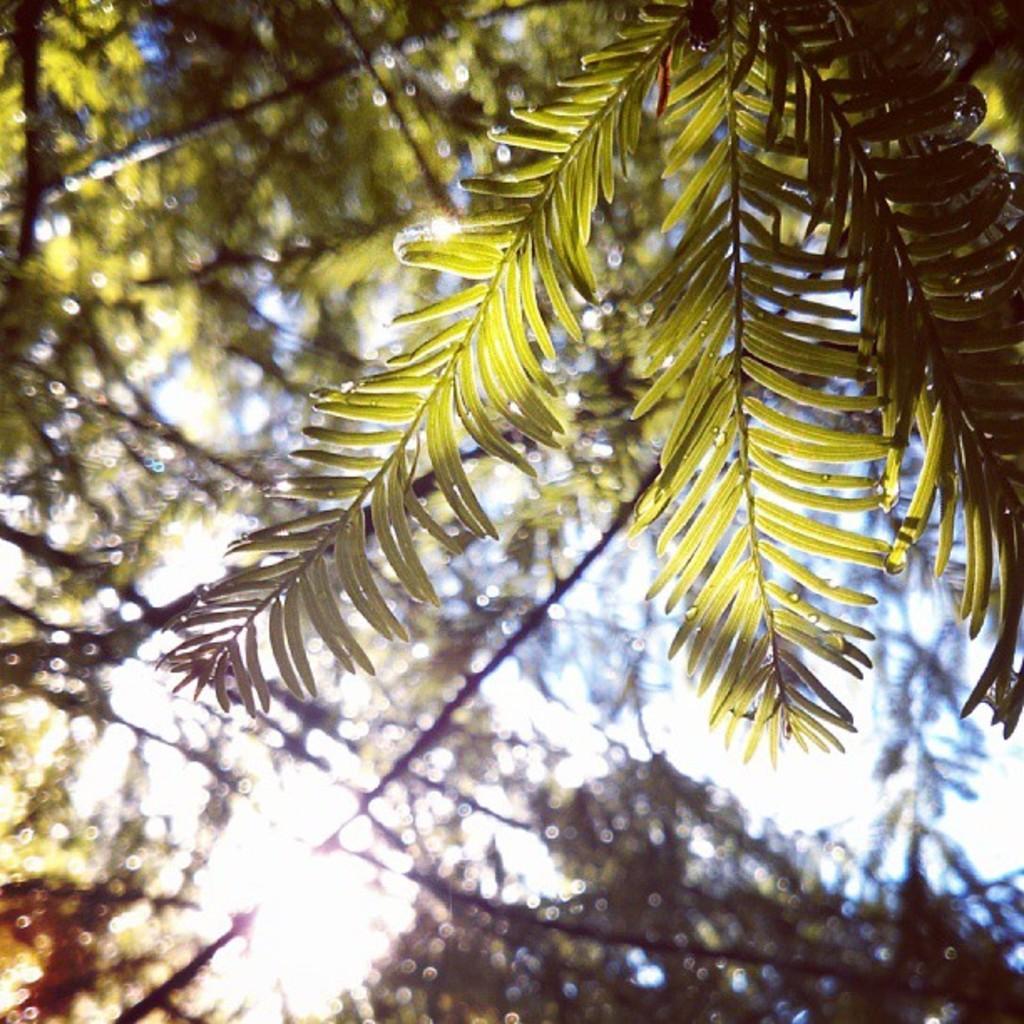Could you give a brief overview of what you see in this image? In the foreground of this picture, we can see leaves of a tree and in the background, there is a tree and the sky. 